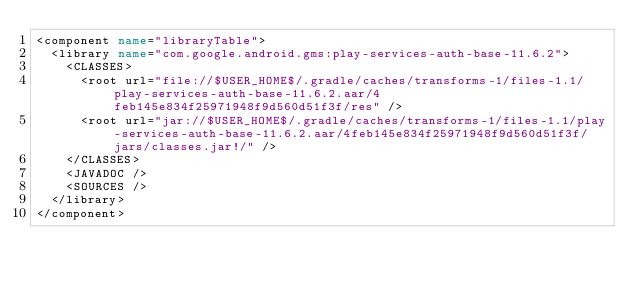<code> <loc_0><loc_0><loc_500><loc_500><_XML_><component name="libraryTable">
  <library name="com.google.android.gms:play-services-auth-base-11.6.2">
    <CLASSES>
      <root url="file://$USER_HOME$/.gradle/caches/transforms-1/files-1.1/play-services-auth-base-11.6.2.aar/4feb145e834f25971948f9d560d51f3f/res" />
      <root url="jar://$USER_HOME$/.gradle/caches/transforms-1/files-1.1/play-services-auth-base-11.6.2.aar/4feb145e834f25971948f9d560d51f3f/jars/classes.jar!/" />
    </CLASSES>
    <JAVADOC />
    <SOURCES />
  </library>
</component></code> 